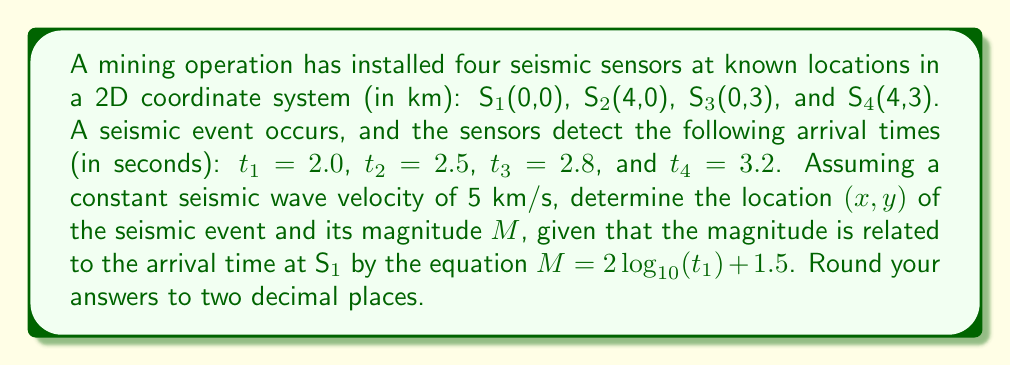What is the answer to this math problem? To solve this inverse problem, we'll use the method of trilateration and the given magnitude equation. Let's proceed step-by-step:

1) First, calculate the distances from each sensor to the event:
   $d_i = v \cdot t_i$, where $v = 5$ km/s
   $d_1 = 5 \cdot 2.0 = 10$ km
   $d_2 = 5 \cdot 2.5 = 12.5$ km
   $d_3 = 5 \cdot 2.8 = 14$ km
   $d_4 = 5 \cdot 3.2 = 16$ km

2) Now, we can set up equations for the distances:
   $$(x-0)^2 + (y-0)^2 = 10^2$$
   $$(x-4)^2 + (y-0)^2 = 12.5^2$$
   $$(x-0)^2 + (y-3)^2 = 14^2$$
   $$(x-4)^2 + (y-3)^2 = 16^2$$

3) Subtracting the first equation from the second:
   $$x^2 - 8x + 16 = 156.25 - 100$$
   $$x^2 - 8x - 40.25 = 0$$

4) Solving this quadratic equation:
   $$x = \frac{8 \pm \sqrt{64 + 161}}{2} = \frac{8 \pm \sqrt{225}}{2} = \frac{8 \pm 15}{2}$$
   $$x = 11.5 \text{ or } -3.5$$

5) Given the sensor locations, x = 11.5 is not feasible, so x ≈ -3.5 km

6) Substituting this back into the first equation:
   $$(-3.5)^2 + y^2 = 10^2$$
   $$y^2 = 100 - 12.25 = 87.75$$
   $$y = \pm \sqrt{87.75} \approx \pm 9.37$$

7) Given the sensor locations, y ≈ 9.37 km

8) To calculate the magnitude:
   $$M = 2\log_{10}(t_1) + 1.5$$
   $$M = 2\log_{10}(2.0) + 1.5$$
   $$M = 2 \cdot 0.3010 + 1.5 = 2.1020$$

Rounding to two decimal places:
x ≈ -3.50 km
y ≈ 9.37 km
M ≈ 2.10
Answer: (-3.50, 9.37), 2.10 